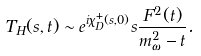<formula> <loc_0><loc_0><loc_500><loc_500>T _ { H } ( s , t ) \sim e ^ { i \chi _ { D } ^ { + } ( s , 0 ) } s \frac { F ^ { 2 } ( t ) } { m _ { \omega } ^ { 2 } - t } .</formula> 